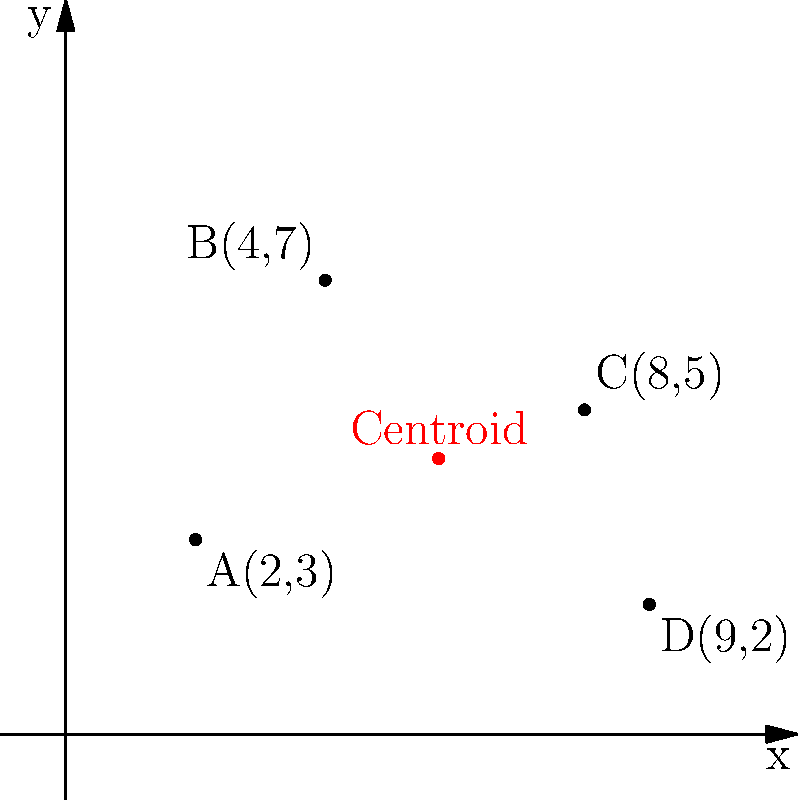A small business owner wants to open a new store location based on the coordinates of their existing customers. Given the customer locations A(2,3), B(4,7), C(8,5), and D(9,2), determine the optimal placement for the new store using the centroid method. What are the coordinates of the centroid (rounded to two decimal places)? To find the optimal placement for the new store using the centroid method, we need to calculate the average of the x-coordinates and y-coordinates of all customer locations:

1. Calculate the average x-coordinate:
   $x_{centroid} = \frac{x_A + x_B + x_C + x_D}{4} = \frac{2 + 4 + 8 + 9}{4} = \frac{23}{4} = 5.75$

2. Calculate the average y-coordinate:
   $y_{centroid} = \frac{y_A + y_B + y_C + y_D}{4} = \frac{3 + 7 + 5 + 2}{4} = \frac{17}{4} = 4.25$

3. The centroid coordinates are (5.75, 4.25).

4. Rounding to two decimal places: (5.75, 4.25)

Therefore, the optimal placement for the new store based on the centroid method is at coordinates (5.75, 4.25).
Answer: (5.75, 4.25) 